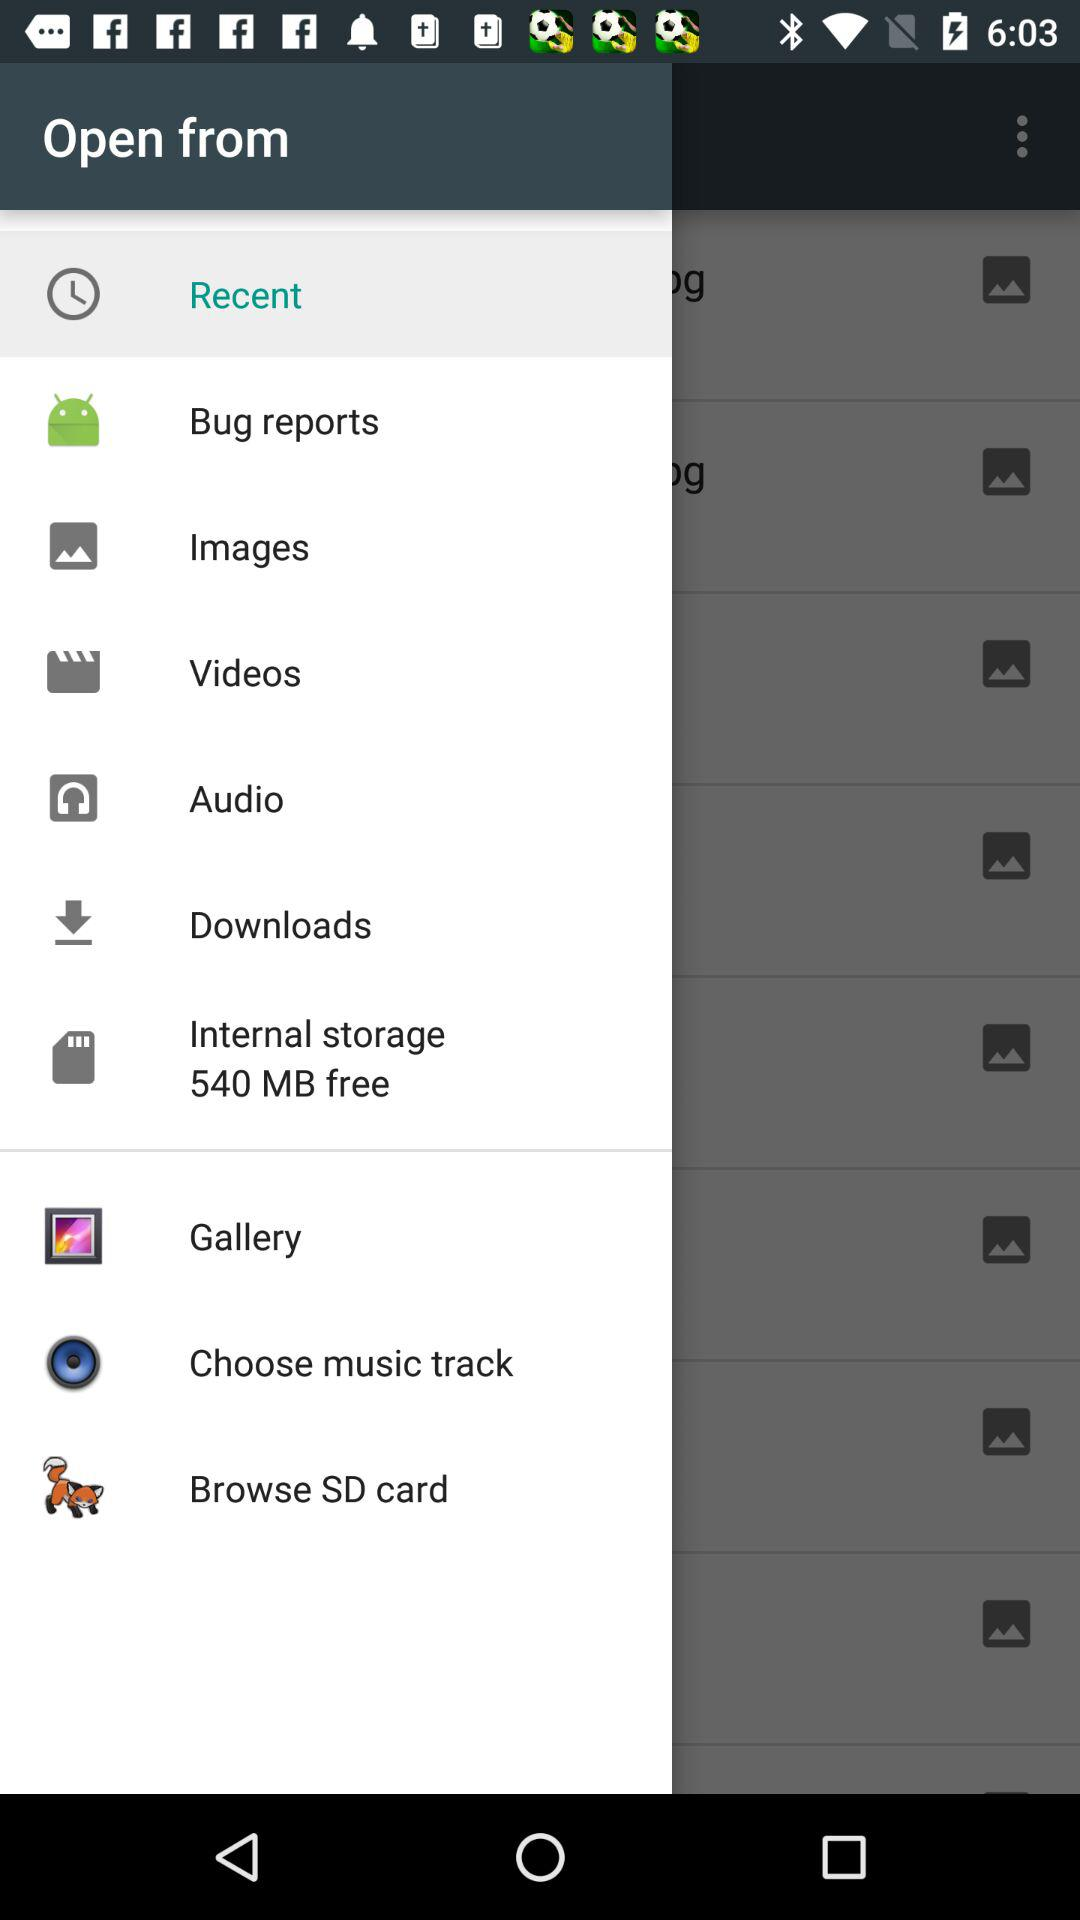How many notifications are there in "Audio"?
When the provided information is insufficient, respond with <no answer>. <no answer> 